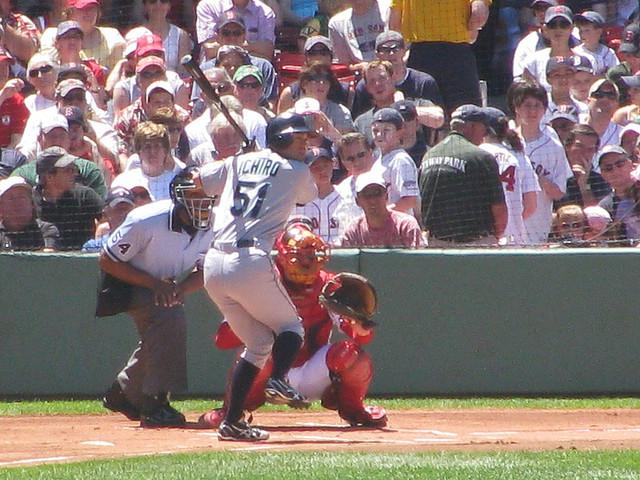What is the net in front of the spectators there for? protection 